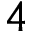<formula> <loc_0><loc_0><loc_500><loc_500>4</formula> 